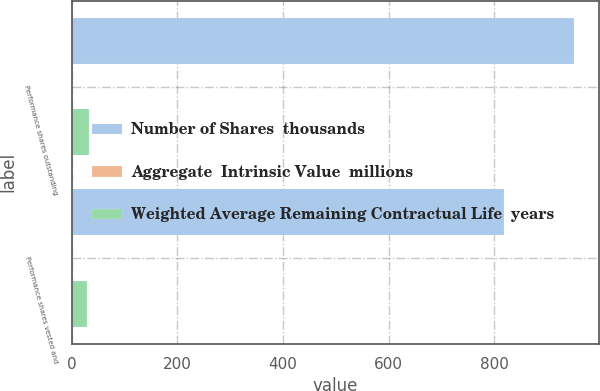Convert chart. <chart><loc_0><loc_0><loc_500><loc_500><stacked_bar_chart><ecel><fcel>Performance shares outstanding<fcel>Performance shares vested and<nl><fcel>Number of Shares  thousands<fcel>950<fcel>818<nl><fcel>Aggregate  Intrinsic Value  millions<fcel>1.05<fcel>0.97<nl><fcel>Weighted Average Remaining Contractual Life  years<fcel>33.6<fcel>28.8<nl></chart> 